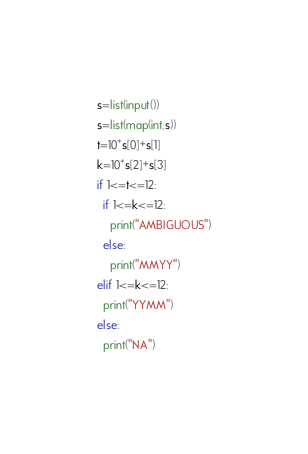Convert code to text. <code><loc_0><loc_0><loc_500><loc_500><_Python_>s=list(input())
s=list(map(int,s))
t=10*s[0]+s[1]
k=10*s[2]+s[3]
if 1<=t<=12:
  if 1<=k<=12:
    print("AMBIGUOUS")
  else:
    print("MMYY")
elif 1<=k<=12:
  print("YYMM")
else:
  print("NA")</code> 